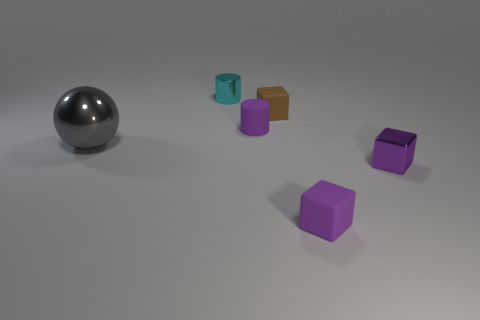Are there more small purple rubber cylinders in front of the shiny block than things to the left of the small brown rubber thing?
Offer a terse response. No. How many large brown blocks have the same material as the small brown thing?
Ensure brevity in your answer.  0. Is the cyan metallic thing the same size as the brown matte cube?
Keep it short and to the point. Yes. The large object has what color?
Your answer should be compact. Gray. How many objects are either brown shiny cylinders or matte things?
Offer a terse response. 3. Are there any other big gray objects of the same shape as the big metal thing?
Offer a very short reply. No. There is a metal object that is in front of the metal ball; does it have the same color as the sphere?
Your answer should be very brief. No. What is the shape of the tiny purple object that is left of the rubber thing that is behind the rubber cylinder?
Ensure brevity in your answer.  Cylinder. Is there a metal ball that has the same size as the rubber cylinder?
Your answer should be very brief. No. Are there fewer cyan objects than small blue matte cylinders?
Ensure brevity in your answer.  No. 